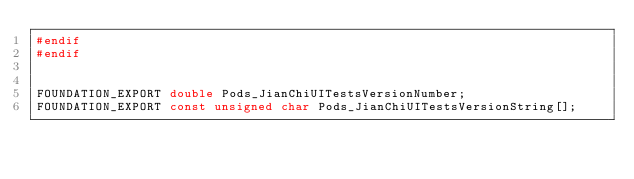<code> <loc_0><loc_0><loc_500><loc_500><_C_>#endif
#endif


FOUNDATION_EXPORT double Pods_JianChiUITestsVersionNumber;
FOUNDATION_EXPORT const unsigned char Pods_JianChiUITestsVersionString[];

</code> 